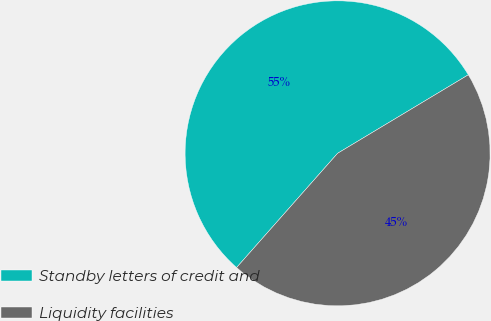Convert chart to OTSL. <chart><loc_0><loc_0><loc_500><loc_500><pie_chart><fcel>Standby letters of credit and<fcel>Liquidity facilities<nl><fcel>54.87%<fcel>45.13%<nl></chart> 